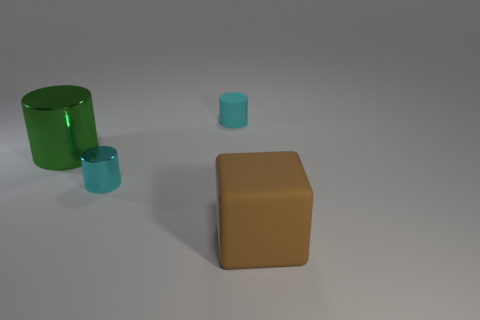There is a small cyan cylinder in front of the rubber thing that is behind the large rubber object; what is its material?
Keep it short and to the point. Metal. There is a brown cube that is the same size as the green shiny thing; what is it made of?
Ensure brevity in your answer.  Rubber. There is a matte object left of the brown rubber thing; does it have the same size as the large brown object?
Give a very brief answer. No. There is a rubber object that is behind the block; does it have the same shape as the big metal object?
Provide a short and direct response. Yes. What number of things are large metallic cylinders or tiny objects that are behind the green metal object?
Your answer should be very brief. 2. Are there fewer brown rubber objects than cyan matte spheres?
Provide a succinct answer. No. Are there more brown things than big blue metallic things?
Provide a succinct answer. Yes. What number of other objects are the same material as the brown thing?
Make the answer very short. 1. There is a big thing that is to the right of the matte object that is left of the large brown cube; how many green shiny cylinders are on the right side of it?
Give a very brief answer. 0. How many rubber things are large cylinders or tiny cyan cylinders?
Keep it short and to the point. 1. 